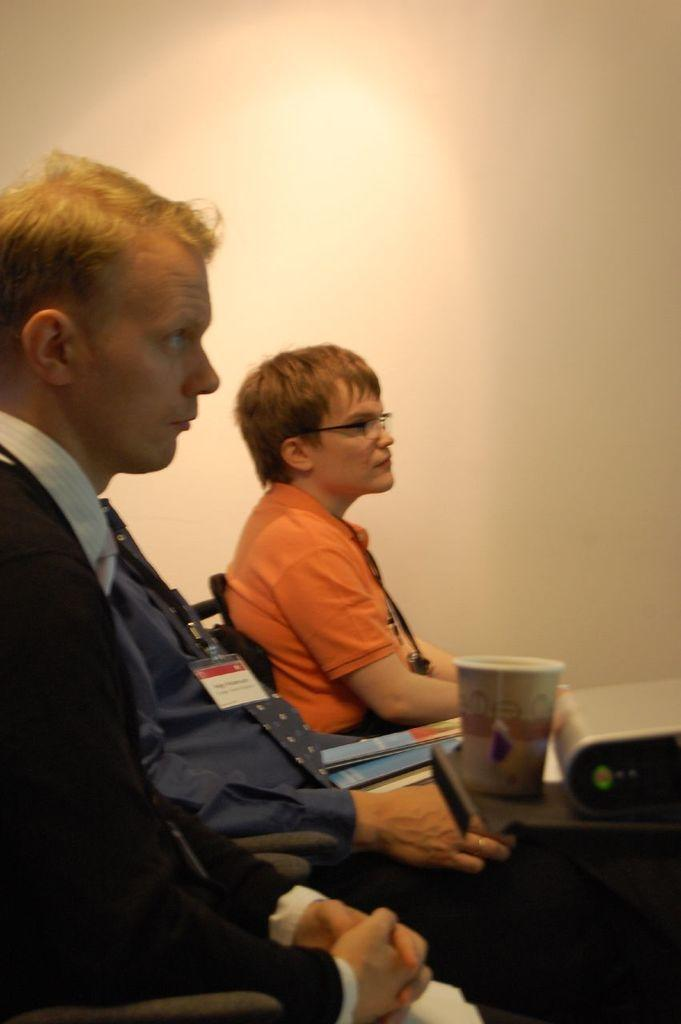How many people are sitting in chairs in the image? There are three people sitting in chairs in the image. What can be seen in the image besides the people sitting in chairs? There is a glass and an object on a tray, which is likely a book, visible in the image. What is visible in the background of the image? There is a wall visible in the background. What type of horn can be seen on the top of the book in the image? There is no horn present in the image, and the object on the tray is likely a book, not a musical instrument. 